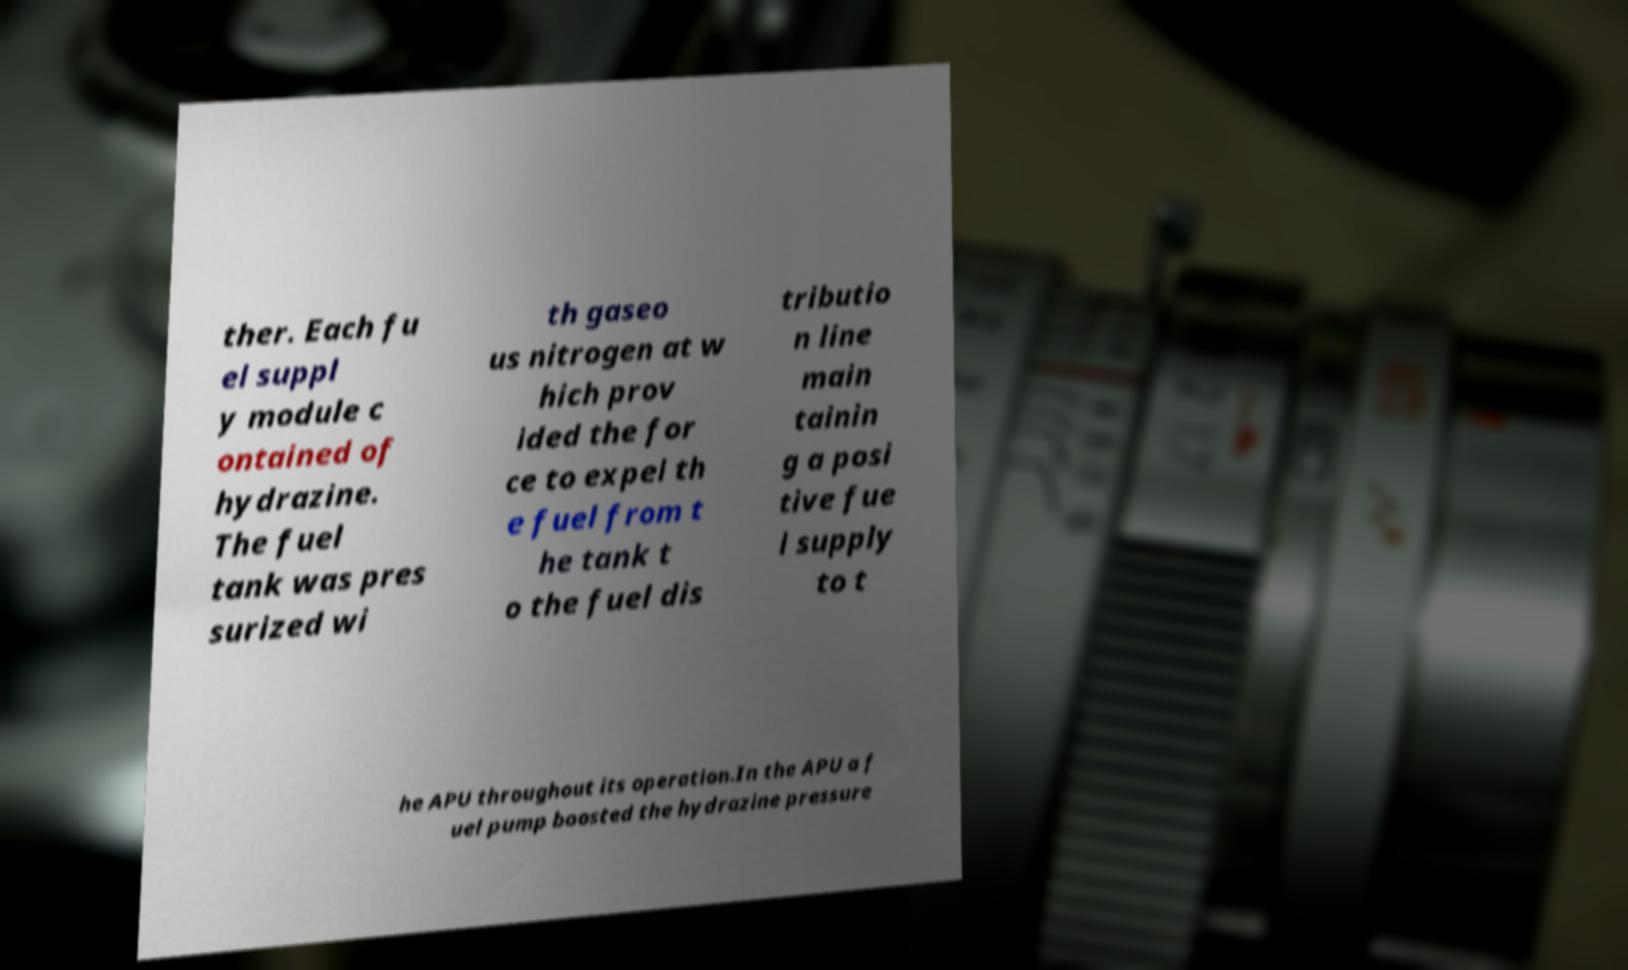Can you read and provide the text displayed in the image?This photo seems to have some interesting text. Can you extract and type it out for me? ther. Each fu el suppl y module c ontained of hydrazine. The fuel tank was pres surized wi th gaseo us nitrogen at w hich prov ided the for ce to expel th e fuel from t he tank t o the fuel dis tributio n line main tainin g a posi tive fue l supply to t he APU throughout its operation.In the APU a f uel pump boosted the hydrazine pressure 